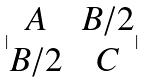Convert formula to latex. <formula><loc_0><loc_0><loc_500><loc_500>| \begin{matrix} A & B / 2 \\ B / 2 & C \end{matrix} |</formula> 